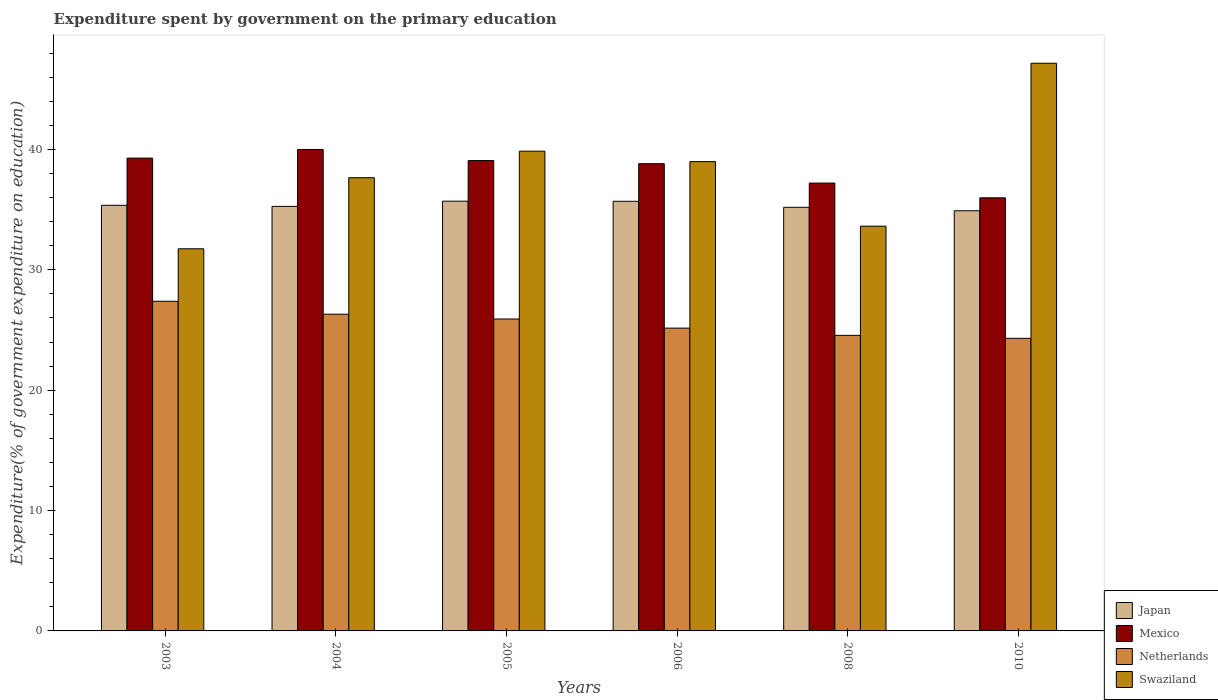How many different coloured bars are there?
Offer a very short reply. 4. How many groups of bars are there?
Your answer should be compact. 6. What is the label of the 3rd group of bars from the left?
Keep it short and to the point. 2005. In how many cases, is the number of bars for a given year not equal to the number of legend labels?
Keep it short and to the point. 0. What is the expenditure spent by government on the primary education in Netherlands in 2006?
Keep it short and to the point. 25.16. Across all years, what is the maximum expenditure spent by government on the primary education in Netherlands?
Ensure brevity in your answer.  27.39. Across all years, what is the minimum expenditure spent by government on the primary education in Japan?
Ensure brevity in your answer.  34.91. In which year was the expenditure spent by government on the primary education in Mexico maximum?
Give a very brief answer. 2004. What is the total expenditure spent by government on the primary education in Mexico in the graph?
Keep it short and to the point. 230.38. What is the difference between the expenditure spent by government on the primary education in Netherlands in 2006 and that in 2010?
Keep it short and to the point. 0.85. What is the difference between the expenditure spent by government on the primary education in Mexico in 2005 and the expenditure spent by government on the primary education in Netherlands in 2003?
Ensure brevity in your answer.  11.69. What is the average expenditure spent by government on the primary education in Mexico per year?
Make the answer very short. 38.4. In the year 2008, what is the difference between the expenditure spent by government on the primary education in Japan and expenditure spent by government on the primary education in Mexico?
Your response must be concise. -2.01. In how many years, is the expenditure spent by government on the primary education in Netherlands greater than 6 %?
Keep it short and to the point. 6. What is the ratio of the expenditure spent by government on the primary education in Swaziland in 2004 to that in 2006?
Give a very brief answer. 0.97. What is the difference between the highest and the second highest expenditure spent by government on the primary education in Swaziland?
Your answer should be compact. 7.31. What is the difference between the highest and the lowest expenditure spent by government on the primary education in Netherlands?
Ensure brevity in your answer.  3.08. In how many years, is the expenditure spent by government on the primary education in Mexico greater than the average expenditure spent by government on the primary education in Mexico taken over all years?
Provide a succinct answer. 4. What does the 4th bar from the left in 2004 represents?
Ensure brevity in your answer.  Swaziland. What does the 1st bar from the right in 2004 represents?
Your answer should be compact. Swaziland. How many bars are there?
Provide a short and direct response. 24. How many years are there in the graph?
Keep it short and to the point. 6. What is the difference between two consecutive major ticks on the Y-axis?
Offer a very short reply. 10. Does the graph contain grids?
Make the answer very short. No. Where does the legend appear in the graph?
Your response must be concise. Bottom right. What is the title of the graph?
Your answer should be compact. Expenditure spent by government on the primary education. Does "Guatemala" appear as one of the legend labels in the graph?
Give a very brief answer. No. What is the label or title of the Y-axis?
Ensure brevity in your answer.  Expenditure(% of government expenditure on education). What is the Expenditure(% of government expenditure on education) in Japan in 2003?
Offer a terse response. 35.36. What is the Expenditure(% of government expenditure on education) of Mexico in 2003?
Give a very brief answer. 39.28. What is the Expenditure(% of government expenditure on education) of Netherlands in 2003?
Make the answer very short. 27.39. What is the Expenditure(% of government expenditure on education) in Swaziland in 2003?
Provide a succinct answer. 31.75. What is the Expenditure(% of government expenditure on education) of Japan in 2004?
Your answer should be very brief. 35.27. What is the Expenditure(% of government expenditure on education) in Mexico in 2004?
Give a very brief answer. 40. What is the Expenditure(% of government expenditure on education) of Netherlands in 2004?
Ensure brevity in your answer.  26.32. What is the Expenditure(% of government expenditure on education) in Swaziland in 2004?
Provide a short and direct response. 37.66. What is the Expenditure(% of government expenditure on education) of Japan in 2005?
Make the answer very short. 35.71. What is the Expenditure(% of government expenditure on education) of Mexico in 2005?
Your answer should be very brief. 39.08. What is the Expenditure(% of government expenditure on education) of Netherlands in 2005?
Ensure brevity in your answer.  25.92. What is the Expenditure(% of government expenditure on education) of Swaziland in 2005?
Your answer should be compact. 39.86. What is the Expenditure(% of government expenditure on education) of Japan in 2006?
Make the answer very short. 35.7. What is the Expenditure(% of government expenditure on education) in Mexico in 2006?
Provide a succinct answer. 38.82. What is the Expenditure(% of government expenditure on education) of Netherlands in 2006?
Your response must be concise. 25.16. What is the Expenditure(% of government expenditure on education) in Swaziland in 2006?
Keep it short and to the point. 38.99. What is the Expenditure(% of government expenditure on education) of Japan in 2008?
Provide a short and direct response. 35.2. What is the Expenditure(% of government expenditure on education) of Mexico in 2008?
Provide a short and direct response. 37.21. What is the Expenditure(% of government expenditure on education) in Netherlands in 2008?
Ensure brevity in your answer.  24.56. What is the Expenditure(% of government expenditure on education) of Swaziland in 2008?
Your response must be concise. 33.63. What is the Expenditure(% of government expenditure on education) in Japan in 2010?
Offer a very short reply. 34.91. What is the Expenditure(% of government expenditure on education) of Mexico in 2010?
Offer a terse response. 35.98. What is the Expenditure(% of government expenditure on education) in Netherlands in 2010?
Offer a very short reply. 24.31. What is the Expenditure(% of government expenditure on education) of Swaziland in 2010?
Give a very brief answer. 47.16. Across all years, what is the maximum Expenditure(% of government expenditure on education) in Japan?
Provide a short and direct response. 35.71. Across all years, what is the maximum Expenditure(% of government expenditure on education) in Mexico?
Your answer should be compact. 40. Across all years, what is the maximum Expenditure(% of government expenditure on education) in Netherlands?
Offer a terse response. 27.39. Across all years, what is the maximum Expenditure(% of government expenditure on education) in Swaziland?
Give a very brief answer. 47.16. Across all years, what is the minimum Expenditure(% of government expenditure on education) of Japan?
Provide a short and direct response. 34.91. Across all years, what is the minimum Expenditure(% of government expenditure on education) in Mexico?
Your answer should be very brief. 35.98. Across all years, what is the minimum Expenditure(% of government expenditure on education) in Netherlands?
Your answer should be very brief. 24.31. Across all years, what is the minimum Expenditure(% of government expenditure on education) in Swaziland?
Offer a very short reply. 31.75. What is the total Expenditure(% of government expenditure on education) in Japan in the graph?
Your answer should be very brief. 212.14. What is the total Expenditure(% of government expenditure on education) in Mexico in the graph?
Offer a very short reply. 230.38. What is the total Expenditure(% of government expenditure on education) in Netherlands in the graph?
Your answer should be very brief. 153.65. What is the total Expenditure(% of government expenditure on education) in Swaziland in the graph?
Offer a very short reply. 229.05. What is the difference between the Expenditure(% of government expenditure on education) in Japan in 2003 and that in 2004?
Offer a very short reply. 0.09. What is the difference between the Expenditure(% of government expenditure on education) in Mexico in 2003 and that in 2004?
Offer a very short reply. -0.72. What is the difference between the Expenditure(% of government expenditure on education) in Netherlands in 2003 and that in 2004?
Your answer should be compact. 1.07. What is the difference between the Expenditure(% of government expenditure on education) in Swaziland in 2003 and that in 2004?
Make the answer very short. -5.91. What is the difference between the Expenditure(% of government expenditure on education) in Japan in 2003 and that in 2005?
Offer a terse response. -0.34. What is the difference between the Expenditure(% of government expenditure on education) in Mexico in 2003 and that in 2005?
Your response must be concise. 0.2. What is the difference between the Expenditure(% of government expenditure on education) in Netherlands in 2003 and that in 2005?
Offer a very short reply. 1.47. What is the difference between the Expenditure(% of government expenditure on education) of Swaziland in 2003 and that in 2005?
Give a very brief answer. -8.11. What is the difference between the Expenditure(% of government expenditure on education) in Japan in 2003 and that in 2006?
Give a very brief answer. -0.33. What is the difference between the Expenditure(% of government expenditure on education) in Mexico in 2003 and that in 2006?
Keep it short and to the point. 0.46. What is the difference between the Expenditure(% of government expenditure on education) in Netherlands in 2003 and that in 2006?
Offer a very short reply. 2.23. What is the difference between the Expenditure(% of government expenditure on education) of Swaziland in 2003 and that in 2006?
Your answer should be very brief. -7.24. What is the difference between the Expenditure(% of government expenditure on education) in Japan in 2003 and that in 2008?
Offer a very short reply. 0.17. What is the difference between the Expenditure(% of government expenditure on education) of Mexico in 2003 and that in 2008?
Offer a very short reply. 2.07. What is the difference between the Expenditure(% of government expenditure on education) in Netherlands in 2003 and that in 2008?
Offer a terse response. 2.83. What is the difference between the Expenditure(% of government expenditure on education) of Swaziland in 2003 and that in 2008?
Keep it short and to the point. -1.88. What is the difference between the Expenditure(% of government expenditure on education) of Japan in 2003 and that in 2010?
Offer a terse response. 0.45. What is the difference between the Expenditure(% of government expenditure on education) of Mexico in 2003 and that in 2010?
Offer a very short reply. 3.3. What is the difference between the Expenditure(% of government expenditure on education) of Netherlands in 2003 and that in 2010?
Make the answer very short. 3.08. What is the difference between the Expenditure(% of government expenditure on education) in Swaziland in 2003 and that in 2010?
Provide a succinct answer. -15.41. What is the difference between the Expenditure(% of government expenditure on education) in Japan in 2004 and that in 2005?
Offer a very short reply. -0.43. What is the difference between the Expenditure(% of government expenditure on education) in Mexico in 2004 and that in 2005?
Make the answer very short. 0.92. What is the difference between the Expenditure(% of government expenditure on education) of Swaziland in 2004 and that in 2005?
Give a very brief answer. -2.2. What is the difference between the Expenditure(% of government expenditure on education) in Japan in 2004 and that in 2006?
Your answer should be very brief. -0.42. What is the difference between the Expenditure(% of government expenditure on education) of Mexico in 2004 and that in 2006?
Your response must be concise. 1.18. What is the difference between the Expenditure(% of government expenditure on education) in Netherlands in 2004 and that in 2006?
Your answer should be compact. 1.16. What is the difference between the Expenditure(% of government expenditure on education) in Swaziland in 2004 and that in 2006?
Give a very brief answer. -1.34. What is the difference between the Expenditure(% of government expenditure on education) in Japan in 2004 and that in 2008?
Provide a short and direct response. 0.08. What is the difference between the Expenditure(% of government expenditure on education) of Mexico in 2004 and that in 2008?
Keep it short and to the point. 2.79. What is the difference between the Expenditure(% of government expenditure on education) in Netherlands in 2004 and that in 2008?
Offer a terse response. 1.76. What is the difference between the Expenditure(% of government expenditure on education) of Swaziland in 2004 and that in 2008?
Make the answer very short. 4.03. What is the difference between the Expenditure(% of government expenditure on education) of Japan in 2004 and that in 2010?
Your answer should be very brief. 0.36. What is the difference between the Expenditure(% of government expenditure on education) in Mexico in 2004 and that in 2010?
Keep it short and to the point. 4.02. What is the difference between the Expenditure(% of government expenditure on education) in Netherlands in 2004 and that in 2010?
Your response must be concise. 2.01. What is the difference between the Expenditure(% of government expenditure on education) in Swaziland in 2004 and that in 2010?
Your answer should be compact. -9.51. What is the difference between the Expenditure(% of government expenditure on education) in Mexico in 2005 and that in 2006?
Offer a very short reply. 0.26. What is the difference between the Expenditure(% of government expenditure on education) in Netherlands in 2005 and that in 2006?
Your answer should be compact. 0.76. What is the difference between the Expenditure(% of government expenditure on education) in Swaziland in 2005 and that in 2006?
Keep it short and to the point. 0.87. What is the difference between the Expenditure(% of government expenditure on education) of Japan in 2005 and that in 2008?
Your answer should be very brief. 0.51. What is the difference between the Expenditure(% of government expenditure on education) of Mexico in 2005 and that in 2008?
Offer a very short reply. 1.87. What is the difference between the Expenditure(% of government expenditure on education) of Netherlands in 2005 and that in 2008?
Provide a succinct answer. 1.36. What is the difference between the Expenditure(% of government expenditure on education) of Swaziland in 2005 and that in 2008?
Your answer should be compact. 6.23. What is the difference between the Expenditure(% of government expenditure on education) in Japan in 2005 and that in 2010?
Your response must be concise. 0.8. What is the difference between the Expenditure(% of government expenditure on education) of Mexico in 2005 and that in 2010?
Your answer should be very brief. 3.1. What is the difference between the Expenditure(% of government expenditure on education) of Netherlands in 2005 and that in 2010?
Give a very brief answer. 1.61. What is the difference between the Expenditure(% of government expenditure on education) of Swaziland in 2005 and that in 2010?
Give a very brief answer. -7.31. What is the difference between the Expenditure(% of government expenditure on education) of Japan in 2006 and that in 2008?
Provide a succinct answer. 0.5. What is the difference between the Expenditure(% of government expenditure on education) in Mexico in 2006 and that in 2008?
Offer a terse response. 1.61. What is the difference between the Expenditure(% of government expenditure on education) in Netherlands in 2006 and that in 2008?
Keep it short and to the point. 0.6. What is the difference between the Expenditure(% of government expenditure on education) of Swaziland in 2006 and that in 2008?
Offer a very short reply. 5.36. What is the difference between the Expenditure(% of government expenditure on education) of Japan in 2006 and that in 2010?
Your answer should be compact. 0.79. What is the difference between the Expenditure(% of government expenditure on education) in Mexico in 2006 and that in 2010?
Ensure brevity in your answer.  2.84. What is the difference between the Expenditure(% of government expenditure on education) in Netherlands in 2006 and that in 2010?
Give a very brief answer. 0.85. What is the difference between the Expenditure(% of government expenditure on education) of Swaziland in 2006 and that in 2010?
Your answer should be compact. -8.17. What is the difference between the Expenditure(% of government expenditure on education) in Japan in 2008 and that in 2010?
Your answer should be very brief. 0.29. What is the difference between the Expenditure(% of government expenditure on education) of Mexico in 2008 and that in 2010?
Keep it short and to the point. 1.22. What is the difference between the Expenditure(% of government expenditure on education) of Netherlands in 2008 and that in 2010?
Provide a succinct answer. 0.25. What is the difference between the Expenditure(% of government expenditure on education) of Swaziland in 2008 and that in 2010?
Your answer should be very brief. -13.54. What is the difference between the Expenditure(% of government expenditure on education) in Japan in 2003 and the Expenditure(% of government expenditure on education) in Mexico in 2004?
Offer a terse response. -4.64. What is the difference between the Expenditure(% of government expenditure on education) of Japan in 2003 and the Expenditure(% of government expenditure on education) of Netherlands in 2004?
Give a very brief answer. 9.05. What is the difference between the Expenditure(% of government expenditure on education) in Japan in 2003 and the Expenditure(% of government expenditure on education) in Swaziland in 2004?
Your answer should be very brief. -2.29. What is the difference between the Expenditure(% of government expenditure on education) in Mexico in 2003 and the Expenditure(% of government expenditure on education) in Netherlands in 2004?
Give a very brief answer. 12.97. What is the difference between the Expenditure(% of government expenditure on education) in Mexico in 2003 and the Expenditure(% of government expenditure on education) in Swaziland in 2004?
Give a very brief answer. 1.63. What is the difference between the Expenditure(% of government expenditure on education) of Netherlands in 2003 and the Expenditure(% of government expenditure on education) of Swaziland in 2004?
Offer a very short reply. -10.27. What is the difference between the Expenditure(% of government expenditure on education) of Japan in 2003 and the Expenditure(% of government expenditure on education) of Mexico in 2005?
Make the answer very short. -3.72. What is the difference between the Expenditure(% of government expenditure on education) of Japan in 2003 and the Expenditure(% of government expenditure on education) of Netherlands in 2005?
Your answer should be compact. 9.45. What is the difference between the Expenditure(% of government expenditure on education) of Japan in 2003 and the Expenditure(% of government expenditure on education) of Swaziland in 2005?
Provide a succinct answer. -4.5. What is the difference between the Expenditure(% of government expenditure on education) in Mexico in 2003 and the Expenditure(% of government expenditure on education) in Netherlands in 2005?
Provide a succinct answer. 13.37. What is the difference between the Expenditure(% of government expenditure on education) of Mexico in 2003 and the Expenditure(% of government expenditure on education) of Swaziland in 2005?
Offer a terse response. -0.58. What is the difference between the Expenditure(% of government expenditure on education) of Netherlands in 2003 and the Expenditure(% of government expenditure on education) of Swaziland in 2005?
Your answer should be compact. -12.47. What is the difference between the Expenditure(% of government expenditure on education) in Japan in 2003 and the Expenditure(% of government expenditure on education) in Mexico in 2006?
Keep it short and to the point. -3.46. What is the difference between the Expenditure(% of government expenditure on education) in Japan in 2003 and the Expenditure(% of government expenditure on education) in Netherlands in 2006?
Your response must be concise. 10.21. What is the difference between the Expenditure(% of government expenditure on education) of Japan in 2003 and the Expenditure(% of government expenditure on education) of Swaziland in 2006?
Your response must be concise. -3.63. What is the difference between the Expenditure(% of government expenditure on education) of Mexico in 2003 and the Expenditure(% of government expenditure on education) of Netherlands in 2006?
Ensure brevity in your answer.  14.13. What is the difference between the Expenditure(% of government expenditure on education) of Mexico in 2003 and the Expenditure(% of government expenditure on education) of Swaziland in 2006?
Give a very brief answer. 0.29. What is the difference between the Expenditure(% of government expenditure on education) in Netherlands in 2003 and the Expenditure(% of government expenditure on education) in Swaziland in 2006?
Your answer should be compact. -11.6. What is the difference between the Expenditure(% of government expenditure on education) in Japan in 2003 and the Expenditure(% of government expenditure on education) in Mexico in 2008?
Offer a very short reply. -1.85. What is the difference between the Expenditure(% of government expenditure on education) of Japan in 2003 and the Expenditure(% of government expenditure on education) of Netherlands in 2008?
Make the answer very short. 10.81. What is the difference between the Expenditure(% of government expenditure on education) in Japan in 2003 and the Expenditure(% of government expenditure on education) in Swaziland in 2008?
Give a very brief answer. 1.73. What is the difference between the Expenditure(% of government expenditure on education) of Mexico in 2003 and the Expenditure(% of government expenditure on education) of Netherlands in 2008?
Keep it short and to the point. 14.73. What is the difference between the Expenditure(% of government expenditure on education) of Mexico in 2003 and the Expenditure(% of government expenditure on education) of Swaziland in 2008?
Your answer should be very brief. 5.65. What is the difference between the Expenditure(% of government expenditure on education) in Netherlands in 2003 and the Expenditure(% of government expenditure on education) in Swaziland in 2008?
Give a very brief answer. -6.24. What is the difference between the Expenditure(% of government expenditure on education) in Japan in 2003 and the Expenditure(% of government expenditure on education) in Mexico in 2010?
Your answer should be very brief. -0.62. What is the difference between the Expenditure(% of government expenditure on education) in Japan in 2003 and the Expenditure(% of government expenditure on education) in Netherlands in 2010?
Provide a short and direct response. 11.05. What is the difference between the Expenditure(% of government expenditure on education) in Japan in 2003 and the Expenditure(% of government expenditure on education) in Swaziland in 2010?
Your answer should be very brief. -11.8. What is the difference between the Expenditure(% of government expenditure on education) in Mexico in 2003 and the Expenditure(% of government expenditure on education) in Netherlands in 2010?
Offer a terse response. 14.97. What is the difference between the Expenditure(% of government expenditure on education) of Mexico in 2003 and the Expenditure(% of government expenditure on education) of Swaziland in 2010?
Provide a succinct answer. -7.88. What is the difference between the Expenditure(% of government expenditure on education) of Netherlands in 2003 and the Expenditure(% of government expenditure on education) of Swaziland in 2010?
Your response must be concise. -19.78. What is the difference between the Expenditure(% of government expenditure on education) of Japan in 2004 and the Expenditure(% of government expenditure on education) of Mexico in 2005?
Your answer should be compact. -3.81. What is the difference between the Expenditure(% of government expenditure on education) in Japan in 2004 and the Expenditure(% of government expenditure on education) in Netherlands in 2005?
Your answer should be very brief. 9.36. What is the difference between the Expenditure(% of government expenditure on education) in Japan in 2004 and the Expenditure(% of government expenditure on education) in Swaziland in 2005?
Make the answer very short. -4.59. What is the difference between the Expenditure(% of government expenditure on education) in Mexico in 2004 and the Expenditure(% of government expenditure on education) in Netherlands in 2005?
Offer a very short reply. 14.09. What is the difference between the Expenditure(% of government expenditure on education) of Mexico in 2004 and the Expenditure(% of government expenditure on education) of Swaziland in 2005?
Give a very brief answer. 0.14. What is the difference between the Expenditure(% of government expenditure on education) in Netherlands in 2004 and the Expenditure(% of government expenditure on education) in Swaziland in 2005?
Your answer should be very brief. -13.54. What is the difference between the Expenditure(% of government expenditure on education) in Japan in 2004 and the Expenditure(% of government expenditure on education) in Mexico in 2006?
Give a very brief answer. -3.55. What is the difference between the Expenditure(% of government expenditure on education) in Japan in 2004 and the Expenditure(% of government expenditure on education) in Netherlands in 2006?
Your response must be concise. 10.11. What is the difference between the Expenditure(% of government expenditure on education) in Japan in 2004 and the Expenditure(% of government expenditure on education) in Swaziland in 2006?
Give a very brief answer. -3.72. What is the difference between the Expenditure(% of government expenditure on education) in Mexico in 2004 and the Expenditure(% of government expenditure on education) in Netherlands in 2006?
Your response must be concise. 14.84. What is the difference between the Expenditure(% of government expenditure on education) of Mexico in 2004 and the Expenditure(% of government expenditure on education) of Swaziland in 2006?
Offer a very short reply. 1.01. What is the difference between the Expenditure(% of government expenditure on education) of Netherlands in 2004 and the Expenditure(% of government expenditure on education) of Swaziland in 2006?
Your answer should be very brief. -12.67. What is the difference between the Expenditure(% of government expenditure on education) in Japan in 2004 and the Expenditure(% of government expenditure on education) in Mexico in 2008?
Offer a terse response. -1.94. What is the difference between the Expenditure(% of government expenditure on education) in Japan in 2004 and the Expenditure(% of government expenditure on education) in Netherlands in 2008?
Give a very brief answer. 10.72. What is the difference between the Expenditure(% of government expenditure on education) of Japan in 2004 and the Expenditure(% of government expenditure on education) of Swaziland in 2008?
Give a very brief answer. 1.64. What is the difference between the Expenditure(% of government expenditure on education) in Mexico in 2004 and the Expenditure(% of government expenditure on education) in Netherlands in 2008?
Make the answer very short. 15.45. What is the difference between the Expenditure(% of government expenditure on education) of Mexico in 2004 and the Expenditure(% of government expenditure on education) of Swaziland in 2008?
Your answer should be very brief. 6.37. What is the difference between the Expenditure(% of government expenditure on education) of Netherlands in 2004 and the Expenditure(% of government expenditure on education) of Swaziland in 2008?
Provide a succinct answer. -7.31. What is the difference between the Expenditure(% of government expenditure on education) of Japan in 2004 and the Expenditure(% of government expenditure on education) of Mexico in 2010?
Your answer should be very brief. -0.71. What is the difference between the Expenditure(% of government expenditure on education) of Japan in 2004 and the Expenditure(% of government expenditure on education) of Netherlands in 2010?
Your response must be concise. 10.96. What is the difference between the Expenditure(% of government expenditure on education) in Japan in 2004 and the Expenditure(% of government expenditure on education) in Swaziland in 2010?
Make the answer very short. -11.89. What is the difference between the Expenditure(% of government expenditure on education) of Mexico in 2004 and the Expenditure(% of government expenditure on education) of Netherlands in 2010?
Your answer should be compact. 15.69. What is the difference between the Expenditure(% of government expenditure on education) in Mexico in 2004 and the Expenditure(% of government expenditure on education) in Swaziland in 2010?
Ensure brevity in your answer.  -7.16. What is the difference between the Expenditure(% of government expenditure on education) in Netherlands in 2004 and the Expenditure(% of government expenditure on education) in Swaziland in 2010?
Your answer should be compact. -20.85. What is the difference between the Expenditure(% of government expenditure on education) in Japan in 2005 and the Expenditure(% of government expenditure on education) in Mexico in 2006?
Keep it short and to the point. -3.12. What is the difference between the Expenditure(% of government expenditure on education) in Japan in 2005 and the Expenditure(% of government expenditure on education) in Netherlands in 2006?
Your response must be concise. 10.55. What is the difference between the Expenditure(% of government expenditure on education) in Japan in 2005 and the Expenditure(% of government expenditure on education) in Swaziland in 2006?
Offer a terse response. -3.29. What is the difference between the Expenditure(% of government expenditure on education) of Mexico in 2005 and the Expenditure(% of government expenditure on education) of Netherlands in 2006?
Provide a succinct answer. 13.92. What is the difference between the Expenditure(% of government expenditure on education) of Mexico in 2005 and the Expenditure(% of government expenditure on education) of Swaziland in 2006?
Offer a terse response. 0.09. What is the difference between the Expenditure(% of government expenditure on education) of Netherlands in 2005 and the Expenditure(% of government expenditure on education) of Swaziland in 2006?
Offer a terse response. -13.07. What is the difference between the Expenditure(% of government expenditure on education) in Japan in 2005 and the Expenditure(% of government expenditure on education) in Mexico in 2008?
Provide a succinct answer. -1.5. What is the difference between the Expenditure(% of government expenditure on education) in Japan in 2005 and the Expenditure(% of government expenditure on education) in Netherlands in 2008?
Provide a succinct answer. 11.15. What is the difference between the Expenditure(% of government expenditure on education) of Japan in 2005 and the Expenditure(% of government expenditure on education) of Swaziland in 2008?
Make the answer very short. 2.08. What is the difference between the Expenditure(% of government expenditure on education) in Mexico in 2005 and the Expenditure(% of government expenditure on education) in Netherlands in 2008?
Offer a very short reply. 14.52. What is the difference between the Expenditure(% of government expenditure on education) of Mexico in 2005 and the Expenditure(% of government expenditure on education) of Swaziland in 2008?
Your answer should be compact. 5.45. What is the difference between the Expenditure(% of government expenditure on education) of Netherlands in 2005 and the Expenditure(% of government expenditure on education) of Swaziland in 2008?
Offer a very short reply. -7.71. What is the difference between the Expenditure(% of government expenditure on education) in Japan in 2005 and the Expenditure(% of government expenditure on education) in Mexico in 2010?
Ensure brevity in your answer.  -0.28. What is the difference between the Expenditure(% of government expenditure on education) in Japan in 2005 and the Expenditure(% of government expenditure on education) in Netherlands in 2010?
Provide a short and direct response. 11.4. What is the difference between the Expenditure(% of government expenditure on education) in Japan in 2005 and the Expenditure(% of government expenditure on education) in Swaziland in 2010?
Your response must be concise. -11.46. What is the difference between the Expenditure(% of government expenditure on education) in Mexico in 2005 and the Expenditure(% of government expenditure on education) in Netherlands in 2010?
Give a very brief answer. 14.77. What is the difference between the Expenditure(% of government expenditure on education) of Mexico in 2005 and the Expenditure(% of government expenditure on education) of Swaziland in 2010?
Your answer should be very brief. -8.09. What is the difference between the Expenditure(% of government expenditure on education) of Netherlands in 2005 and the Expenditure(% of government expenditure on education) of Swaziland in 2010?
Give a very brief answer. -21.25. What is the difference between the Expenditure(% of government expenditure on education) of Japan in 2006 and the Expenditure(% of government expenditure on education) of Mexico in 2008?
Ensure brevity in your answer.  -1.51. What is the difference between the Expenditure(% of government expenditure on education) in Japan in 2006 and the Expenditure(% of government expenditure on education) in Netherlands in 2008?
Provide a succinct answer. 11.14. What is the difference between the Expenditure(% of government expenditure on education) of Japan in 2006 and the Expenditure(% of government expenditure on education) of Swaziland in 2008?
Ensure brevity in your answer.  2.07. What is the difference between the Expenditure(% of government expenditure on education) in Mexico in 2006 and the Expenditure(% of government expenditure on education) in Netherlands in 2008?
Give a very brief answer. 14.26. What is the difference between the Expenditure(% of government expenditure on education) in Mexico in 2006 and the Expenditure(% of government expenditure on education) in Swaziland in 2008?
Your answer should be very brief. 5.19. What is the difference between the Expenditure(% of government expenditure on education) in Netherlands in 2006 and the Expenditure(% of government expenditure on education) in Swaziland in 2008?
Your response must be concise. -8.47. What is the difference between the Expenditure(% of government expenditure on education) in Japan in 2006 and the Expenditure(% of government expenditure on education) in Mexico in 2010?
Your answer should be very brief. -0.29. What is the difference between the Expenditure(% of government expenditure on education) in Japan in 2006 and the Expenditure(% of government expenditure on education) in Netherlands in 2010?
Provide a succinct answer. 11.39. What is the difference between the Expenditure(% of government expenditure on education) in Japan in 2006 and the Expenditure(% of government expenditure on education) in Swaziland in 2010?
Your response must be concise. -11.47. What is the difference between the Expenditure(% of government expenditure on education) in Mexico in 2006 and the Expenditure(% of government expenditure on education) in Netherlands in 2010?
Ensure brevity in your answer.  14.51. What is the difference between the Expenditure(% of government expenditure on education) of Mexico in 2006 and the Expenditure(% of government expenditure on education) of Swaziland in 2010?
Your answer should be very brief. -8.34. What is the difference between the Expenditure(% of government expenditure on education) of Netherlands in 2006 and the Expenditure(% of government expenditure on education) of Swaziland in 2010?
Provide a succinct answer. -22.01. What is the difference between the Expenditure(% of government expenditure on education) of Japan in 2008 and the Expenditure(% of government expenditure on education) of Mexico in 2010?
Keep it short and to the point. -0.79. What is the difference between the Expenditure(% of government expenditure on education) in Japan in 2008 and the Expenditure(% of government expenditure on education) in Netherlands in 2010?
Your response must be concise. 10.89. What is the difference between the Expenditure(% of government expenditure on education) in Japan in 2008 and the Expenditure(% of government expenditure on education) in Swaziland in 2010?
Provide a succinct answer. -11.97. What is the difference between the Expenditure(% of government expenditure on education) in Mexico in 2008 and the Expenditure(% of government expenditure on education) in Netherlands in 2010?
Offer a terse response. 12.9. What is the difference between the Expenditure(% of government expenditure on education) of Mexico in 2008 and the Expenditure(% of government expenditure on education) of Swaziland in 2010?
Offer a terse response. -9.96. What is the difference between the Expenditure(% of government expenditure on education) in Netherlands in 2008 and the Expenditure(% of government expenditure on education) in Swaziland in 2010?
Your answer should be compact. -22.61. What is the average Expenditure(% of government expenditure on education) in Japan per year?
Ensure brevity in your answer.  35.36. What is the average Expenditure(% of government expenditure on education) of Mexico per year?
Your answer should be compact. 38.4. What is the average Expenditure(% of government expenditure on education) in Netherlands per year?
Provide a succinct answer. 25.61. What is the average Expenditure(% of government expenditure on education) of Swaziland per year?
Your response must be concise. 38.17. In the year 2003, what is the difference between the Expenditure(% of government expenditure on education) of Japan and Expenditure(% of government expenditure on education) of Mexico?
Make the answer very short. -3.92. In the year 2003, what is the difference between the Expenditure(% of government expenditure on education) of Japan and Expenditure(% of government expenditure on education) of Netherlands?
Provide a short and direct response. 7.97. In the year 2003, what is the difference between the Expenditure(% of government expenditure on education) of Japan and Expenditure(% of government expenditure on education) of Swaziland?
Ensure brevity in your answer.  3.61. In the year 2003, what is the difference between the Expenditure(% of government expenditure on education) in Mexico and Expenditure(% of government expenditure on education) in Netherlands?
Keep it short and to the point. 11.89. In the year 2003, what is the difference between the Expenditure(% of government expenditure on education) in Mexico and Expenditure(% of government expenditure on education) in Swaziland?
Your response must be concise. 7.53. In the year 2003, what is the difference between the Expenditure(% of government expenditure on education) in Netherlands and Expenditure(% of government expenditure on education) in Swaziland?
Your answer should be compact. -4.36. In the year 2004, what is the difference between the Expenditure(% of government expenditure on education) in Japan and Expenditure(% of government expenditure on education) in Mexico?
Your answer should be very brief. -4.73. In the year 2004, what is the difference between the Expenditure(% of government expenditure on education) in Japan and Expenditure(% of government expenditure on education) in Netherlands?
Offer a terse response. 8.96. In the year 2004, what is the difference between the Expenditure(% of government expenditure on education) of Japan and Expenditure(% of government expenditure on education) of Swaziland?
Provide a succinct answer. -2.38. In the year 2004, what is the difference between the Expenditure(% of government expenditure on education) in Mexico and Expenditure(% of government expenditure on education) in Netherlands?
Make the answer very short. 13.69. In the year 2004, what is the difference between the Expenditure(% of government expenditure on education) of Mexico and Expenditure(% of government expenditure on education) of Swaziland?
Your answer should be very brief. 2.35. In the year 2004, what is the difference between the Expenditure(% of government expenditure on education) in Netherlands and Expenditure(% of government expenditure on education) in Swaziland?
Offer a terse response. -11.34. In the year 2005, what is the difference between the Expenditure(% of government expenditure on education) of Japan and Expenditure(% of government expenditure on education) of Mexico?
Offer a very short reply. -3.37. In the year 2005, what is the difference between the Expenditure(% of government expenditure on education) in Japan and Expenditure(% of government expenditure on education) in Netherlands?
Offer a very short reply. 9.79. In the year 2005, what is the difference between the Expenditure(% of government expenditure on education) in Japan and Expenditure(% of government expenditure on education) in Swaziland?
Make the answer very short. -4.15. In the year 2005, what is the difference between the Expenditure(% of government expenditure on education) of Mexico and Expenditure(% of government expenditure on education) of Netherlands?
Ensure brevity in your answer.  13.16. In the year 2005, what is the difference between the Expenditure(% of government expenditure on education) of Mexico and Expenditure(% of government expenditure on education) of Swaziland?
Your answer should be compact. -0.78. In the year 2005, what is the difference between the Expenditure(% of government expenditure on education) of Netherlands and Expenditure(% of government expenditure on education) of Swaziland?
Give a very brief answer. -13.94. In the year 2006, what is the difference between the Expenditure(% of government expenditure on education) in Japan and Expenditure(% of government expenditure on education) in Mexico?
Your response must be concise. -3.13. In the year 2006, what is the difference between the Expenditure(% of government expenditure on education) of Japan and Expenditure(% of government expenditure on education) of Netherlands?
Provide a succinct answer. 10.54. In the year 2006, what is the difference between the Expenditure(% of government expenditure on education) of Japan and Expenditure(% of government expenditure on education) of Swaziland?
Give a very brief answer. -3.3. In the year 2006, what is the difference between the Expenditure(% of government expenditure on education) in Mexico and Expenditure(% of government expenditure on education) in Netherlands?
Your response must be concise. 13.66. In the year 2006, what is the difference between the Expenditure(% of government expenditure on education) in Mexico and Expenditure(% of government expenditure on education) in Swaziland?
Offer a terse response. -0.17. In the year 2006, what is the difference between the Expenditure(% of government expenditure on education) of Netherlands and Expenditure(% of government expenditure on education) of Swaziland?
Offer a terse response. -13.83. In the year 2008, what is the difference between the Expenditure(% of government expenditure on education) in Japan and Expenditure(% of government expenditure on education) in Mexico?
Ensure brevity in your answer.  -2.01. In the year 2008, what is the difference between the Expenditure(% of government expenditure on education) of Japan and Expenditure(% of government expenditure on education) of Netherlands?
Offer a very short reply. 10.64. In the year 2008, what is the difference between the Expenditure(% of government expenditure on education) in Japan and Expenditure(% of government expenditure on education) in Swaziland?
Ensure brevity in your answer.  1.57. In the year 2008, what is the difference between the Expenditure(% of government expenditure on education) of Mexico and Expenditure(% of government expenditure on education) of Netherlands?
Ensure brevity in your answer.  12.65. In the year 2008, what is the difference between the Expenditure(% of government expenditure on education) in Mexico and Expenditure(% of government expenditure on education) in Swaziland?
Your response must be concise. 3.58. In the year 2008, what is the difference between the Expenditure(% of government expenditure on education) of Netherlands and Expenditure(% of government expenditure on education) of Swaziland?
Offer a very short reply. -9.07. In the year 2010, what is the difference between the Expenditure(% of government expenditure on education) of Japan and Expenditure(% of government expenditure on education) of Mexico?
Your answer should be compact. -1.07. In the year 2010, what is the difference between the Expenditure(% of government expenditure on education) of Japan and Expenditure(% of government expenditure on education) of Netherlands?
Offer a very short reply. 10.6. In the year 2010, what is the difference between the Expenditure(% of government expenditure on education) of Japan and Expenditure(% of government expenditure on education) of Swaziland?
Provide a succinct answer. -12.26. In the year 2010, what is the difference between the Expenditure(% of government expenditure on education) in Mexico and Expenditure(% of government expenditure on education) in Netherlands?
Make the answer very short. 11.67. In the year 2010, what is the difference between the Expenditure(% of government expenditure on education) in Mexico and Expenditure(% of government expenditure on education) in Swaziland?
Offer a terse response. -11.18. In the year 2010, what is the difference between the Expenditure(% of government expenditure on education) in Netherlands and Expenditure(% of government expenditure on education) in Swaziland?
Provide a short and direct response. -22.85. What is the ratio of the Expenditure(% of government expenditure on education) in Japan in 2003 to that in 2004?
Make the answer very short. 1. What is the ratio of the Expenditure(% of government expenditure on education) of Mexico in 2003 to that in 2004?
Your answer should be very brief. 0.98. What is the ratio of the Expenditure(% of government expenditure on education) of Netherlands in 2003 to that in 2004?
Your answer should be very brief. 1.04. What is the ratio of the Expenditure(% of government expenditure on education) of Swaziland in 2003 to that in 2004?
Your answer should be compact. 0.84. What is the ratio of the Expenditure(% of government expenditure on education) in Japan in 2003 to that in 2005?
Offer a terse response. 0.99. What is the ratio of the Expenditure(% of government expenditure on education) of Netherlands in 2003 to that in 2005?
Keep it short and to the point. 1.06. What is the ratio of the Expenditure(% of government expenditure on education) of Swaziland in 2003 to that in 2005?
Offer a terse response. 0.8. What is the ratio of the Expenditure(% of government expenditure on education) of Mexico in 2003 to that in 2006?
Make the answer very short. 1.01. What is the ratio of the Expenditure(% of government expenditure on education) in Netherlands in 2003 to that in 2006?
Ensure brevity in your answer.  1.09. What is the ratio of the Expenditure(% of government expenditure on education) in Swaziland in 2003 to that in 2006?
Offer a very short reply. 0.81. What is the ratio of the Expenditure(% of government expenditure on education) of Japan in 2003 to that in 2008?
Your response must be concise. 1. What is the ratio of the Expenditure(% of government expenditure on education) of Mexico in 2003 to that in 2008?
Keep it short and to the point. 1.06. What is the ratio of the Expenditure(% of government expenditure on education) of Netherlands in 2003 to that in 2008?
Provide a short and direct response. 1.12. What is the ratio of the Expenditure(% of government expenditure on education) in Swaziland in 2003 to that in 2008?
Your answer should be very brief. 0.94. What is the ratio of the Expenditure(% of government expenditure on education) in Japan in 2003 to that in 2010?
Keep it short and to the point. 1.01. What is the ratio of the Expenditure(% of government expenditure on education) of Mexico in 2003 to that in 2010?
Your answer should be compact. 1.09. What is the ratio of the Expenditure(% of government expenditure on education) in Netherlands in 2003 to that in 2010?
Your answer should be compact. 1.13. What is the ratio of the Expenditure(% of government expenditure on education) in Swaziland in 2003 to that in 2010?
Keep it short and to the point. 0.67. What is the ratio of the Expenditure(% of government expenditure on education) in Japan in 2004 to that in 2005?
Ensure brevity in your answer.  0.99. What is the ratio of the Expenditure(% of government expenditure on education) of Mexico in 2004 to that in 2005?
Offer a very short reply. 1.02. What is the ratio of the Expenditure(% of government expenditure on education) of Netherlands in 2004 to that in 2005?
Offer a terse response. 1.02. What is the ratio of the Expenditure(% of government expenditure on education) in Swaziland in 2004 to that in 2005?
Ensure brevity in your answer.  0.94. What is the ratio of the Expenditure(% of government expenditure on education) in Japan in 2004 to that in 2006?
Make the answer very short. 0.99. What is the ratio of the Expenditure(% of government expenditure on education) of Mexico in 2004 to that in 2006?
Make the answer very short. 1.03. What is the ratio of the Expenditure(% of government expenditure on education) in Netherlands in 2004 to that in 2006?
Provide a short and direct response. 1.05. What is the ratio of the Expenditure(% of government expenditure on education) of Swaziland in 2004 to that in 2006?
Ensure brevity in your answer.  0.97. What is the ratio of the Expenditure(% of government expenditure on education) of Mexico in 2004 to that in 2008?
Give a very brief answer. 1.08. What is the ratio of the Expenditure(% of government expenditure on education) of Netherlands in 2004 to that in 2008?
Provide a short and direct response. 1.07. What is the ratio of the Expenditure(% of government expenditure on education) in Swaziland in 2004 to that in 2008?
Keep it short and to the point. 1.12. What is the ratio of the Expenditure(% of government expenditure on education) of Japan in 2004 to that in 2010?
Provide a succinct answer. 1.01. What is the ratio of the Expenditure(% of government expenditure on education) in Mexico in 2004 to that in 2010?
Offer a very short reply. 1.11. What is the ratio of the Expenditure(% of government expenditure on education) in Netherlands in 2004 to that in 2010?
Provide a succinct answer. 1.08. What is the ratio of the Expenditure(% of government expenditure on education) of Swaziland in 2004 to that in 2010?
Provide a succinct answer. 0.8. What is the ratio of the Expenditure(% of government expenditure on education) of Mexico in 2005 to that in 2006?
Keep it short and to the point. 1.01. What is the ratio of the Expenditure(% of government expenditure on education) in Netherlands in 2005 to that in 2006?
Your answer should be compact. 1.03. What is the ratio of the Expenditure(% of government expenditure on education) in Swaziland in 2005 to that in 2006?
Make the answer very short. 1.02. What is the ratio of the Expenditure(% of government expenditure on education) of Japan in 2005 to that in 2008?
Make the answer very short. 1.01. What is the ratio of the Expenditure(% of government expenditure on education) of Mexico in 2005 to that in 2008?
Offer a terse response. 1.05. What is the ratio of the Expenditure(% of government expenditure on education) in Netherlands in 2005 to that in 2008?
Offer a very short reply. 1.06. What is the ratio of the Expenditure(% of government expenditure on education) in Swaziland in 2005 to that in 2008?
Ensure brevity in your answer.  1.19. What is the ratio of the Expenditure(% of government expenditure on education) in Japan in 2005 to that in 2010?
Provide a short and direct response. 1.02. What is the ratio of the Expenditure(% of government expenditure on education) of Mexico in 2005 to that in 2010?
Provide a short and direct response. 1.09. What is the ratio of the Expenditure(% of government expenditure on education) in Netherlands in 2005 to that in 2010?
Your response must be concise. 1.07. What is the ratio of the Expenditure(% of government expenditure on education) in Swaziland in 2005 to that in 2010?
Provide a succinct answer. 0.85. What is the ratio of the Expenditure(% of government expenditure on education) of Japan in 2006 to that in 2008?
Give a very brief answer. 1.01. What is the ratio of the Expenditure(% of government expenditure on education) in Mexico in 2006 to that in 2008?
Your answer should be very brief. 1.04. What is the ratio of the Expenditure(% of government expenditure on education) of Netherlands in 2006 to that in 2008?
Your response must be concise. 1.02. What is the ratio of the Expenditure(% of government expenditure on education) of Swaziland in 2006 to that in 2008?
Provide a succinct answer. 1.16. What is the ratio of the Expenditure(% of government expenditure on education) in Japan in 2006 to that in 2010?
Offer a terse response. 1.02. What is the ratio of the Expenditure(% of government expenditure on education) in Mexico in 2006 to that in 2010?
Ensure brevity in your answer.  1.08. What is the ratio of the Expenditure(% of government expenditure on education) in Netherlands in 2006 to that in 2010?
Offer a very short reply. 1.03. What is the ratio of the Expenditure(% of government expenditure on education) of Swaziland in 2006 to that in 2010?
Keep it short and to the point. 0.83. What is the ratio of the Expenditure(% of government expenditure on education) of Japan in 2008 to that in 2010?
Keep it short and to the point. 1.01. What is the ratio of the Expenditure(% of government expenditure on education) of Mexico in 2008 to that in 2010?
Ensure brevity in your answer.  1.03. What is the ratio of the Expenditure(% of government expenditure on education) in Netherlands in 2008 to that in 2010?
Ensure brevity in your answer.  1.01. What is the ratio of the Expenditure(% of government expenditure on education) in Swaziland in 2008 to that in 2010?
Your response must be concise. 0.71. What is the difference between the highest and the second highest Expenditure(% of government expenditure on education) in Mexico?
Ensure brevity in your answer.  0.72. What is the difference between the highest and the second highest Expenditure(% of government expenditure on education) in Netherlands?
Make the answer very short. 1.07. What is the difference between the highest and the second highest Expenditure(% of government expenditure on education) in Swaziland?
Your answer should be compact. 7.31. What is the difference between the highest and the lowest Expenditure(% of government expenditure on education) of Japan?
Keep it short and to the point. 0.8. What is the difference between the highest and the lowest Expenditure(% of government expenditure on education) of Mexico?
Your answer should be compact. 4.02. What is the difference between the highest and the lowest Expenditure(% of government expenditure on education) in Netherlands?
Provide a succinct answer. 3.08. What is the difference between the highest and the lowest Expenditure(% of government expenditure on education) in Swaziland?
Provide a succinct answer. 15.41. 